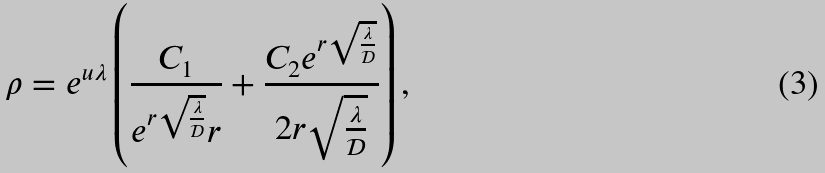Convert formula to latex. <formula><loc_0><loc_0><loc_500><loc_500>\rho = e ^ { u \lambda } \left ( \frac { C _ { 1 } } { e ^ { r \sqrt { \frac { \lambda } { \mathcal { D } } } } r } + \frac { C _ { 2 } e ^ { r \sqrt { \frac { \lambda } { \mathcal { D } } } } } { 2 r \sqrt { \frac { \lambda } { \mathcal { D } } } } \right ) ,</formula> 